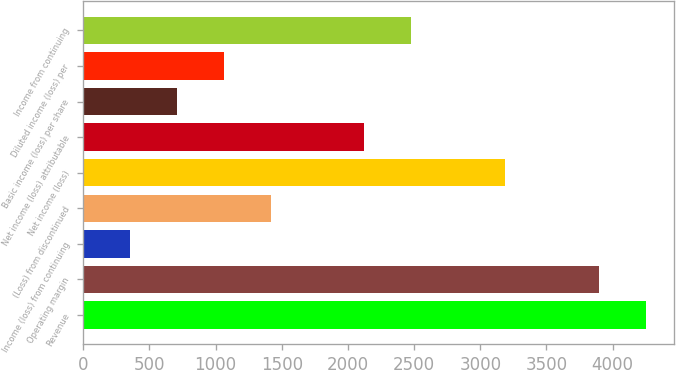Convert chart to OTSL. <chart><loc_0><loc_0><loc_500><loc_500><bar_chart><fcel>Revenue<fcel>Operating margin<fcel>Income (loss) from continuing<fcel>(Loss) from discontinued<fcel>Net income (loss)<fcel>Net income (loss) attributable<fcel>Basic income (loss) per share<fcel>Diluted income (loss) per<fcel>Income from continuing<nl><fcel>4250.41<fcel>3896.21<fcel>354.21<fcel>1416.81<fcel>3187.81<fcel>2125.21<fcel>708.41<fcel>1062.61<fcel>2479.41<nl></chart> 